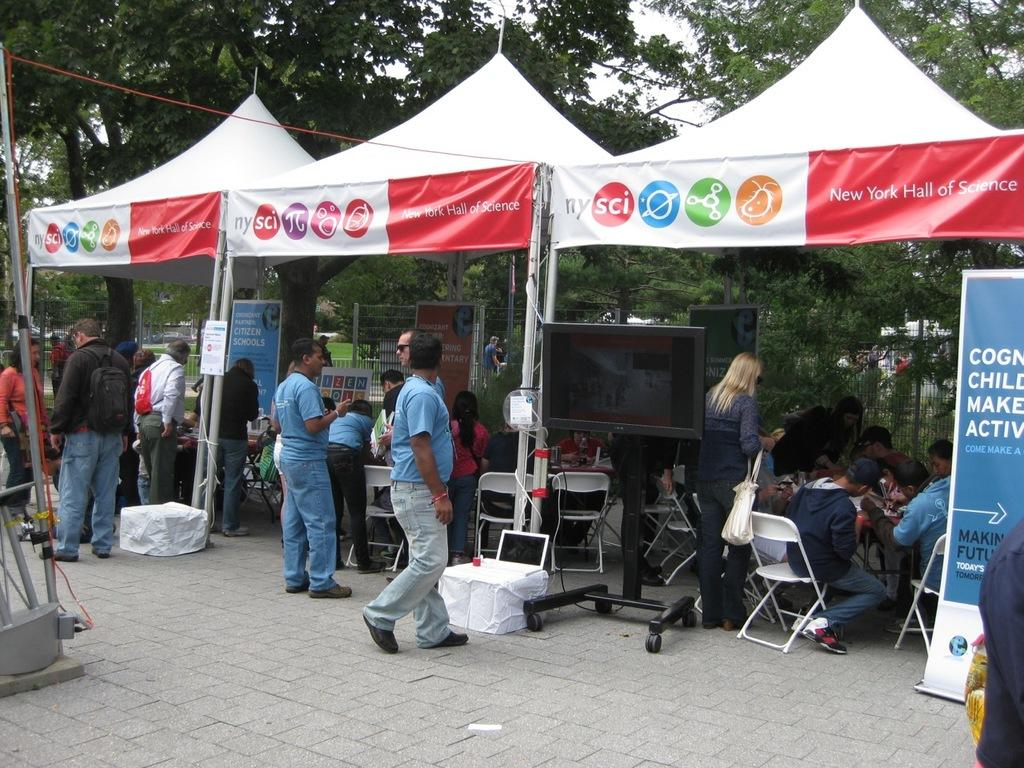What can be seen in the image? There are people standing in the image, along with canopies, chairs, banners, a screen, trees, and the sky. What might the people be doing in the image? The presence of chairs, canopies, and a screen suggests that the people might be attending an outdoor event or gathering. What type of structures are present in the image? Canopies and a screen are visible in the image. What is the natural setting visible in the image? Trees and the sky are visible in the image. Can you see a mountain in the background of the image? There is no mountain visible in the image; it features trees and the sky in the background. What type of fruit is being served on the chairs in the image? There is no fruit, specifically pears, present on the chairs in the image. 